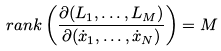<formula> <loc_0><loc_0><loc_500><loc_500>r a n k \left ( \frac { \partial ( L _ { 1 } , \dots , L _ { M } ) } { \partial ( \dot { x } _ { 1 } , \dots , \dot { x } _ { N } ) } \right ) = M</formula> 